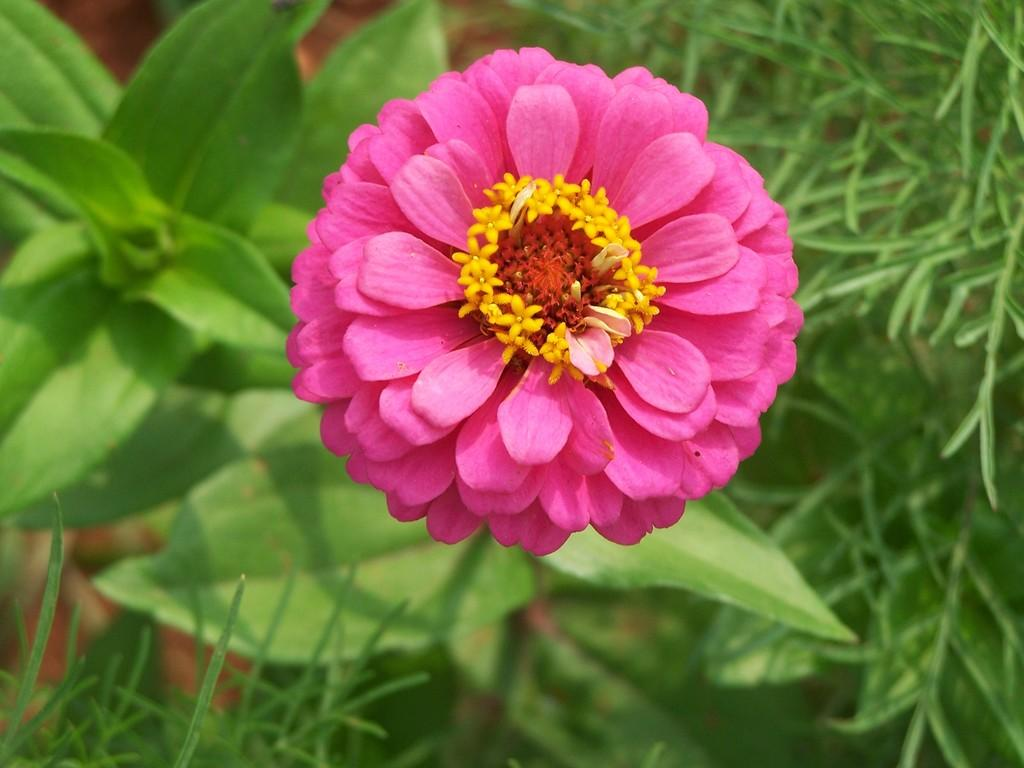What is the main subject of the image? There is a flower in the image. Where is the flower located? The flower is on a plant. What can be seen in the background of the image? There is grass in the background of the image. How many laborers are working in the field behind the flower? There is no field or laborers present in the image; it only features a flower on a plant and grass in the background. What type of turkey can be seen grazing in the grass? There is no turkey present in the image; it only features a flower on a plant and grass in the background. 